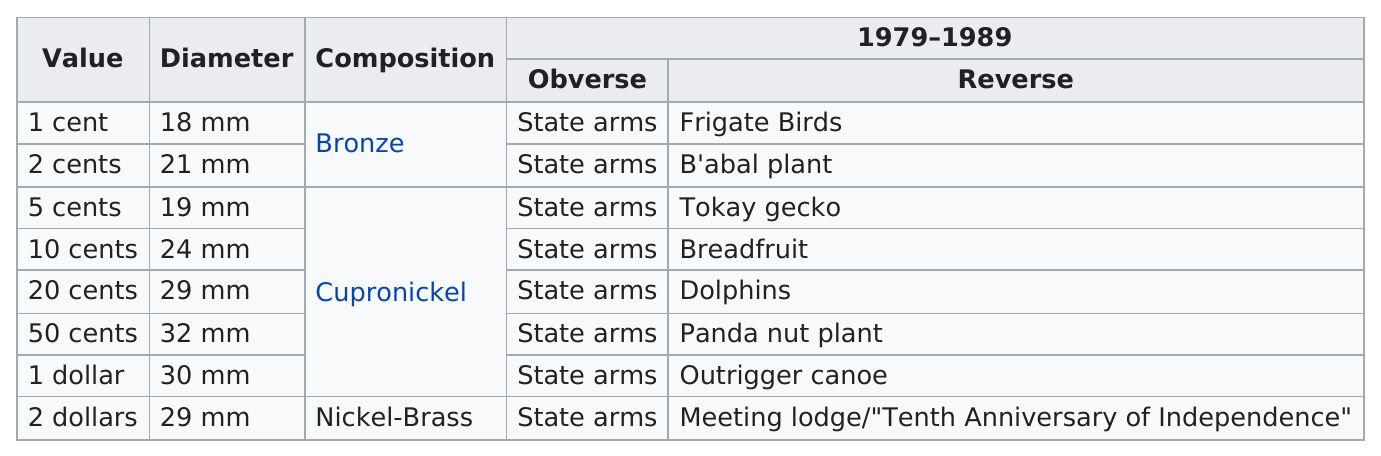Point out several critical features in this image. The obverse side of each coin features the Coat of Arms of the issuing country, showcasing the national symbolism and pride of the nation. It is estimated that only 5 coins are made of cupronickle. 